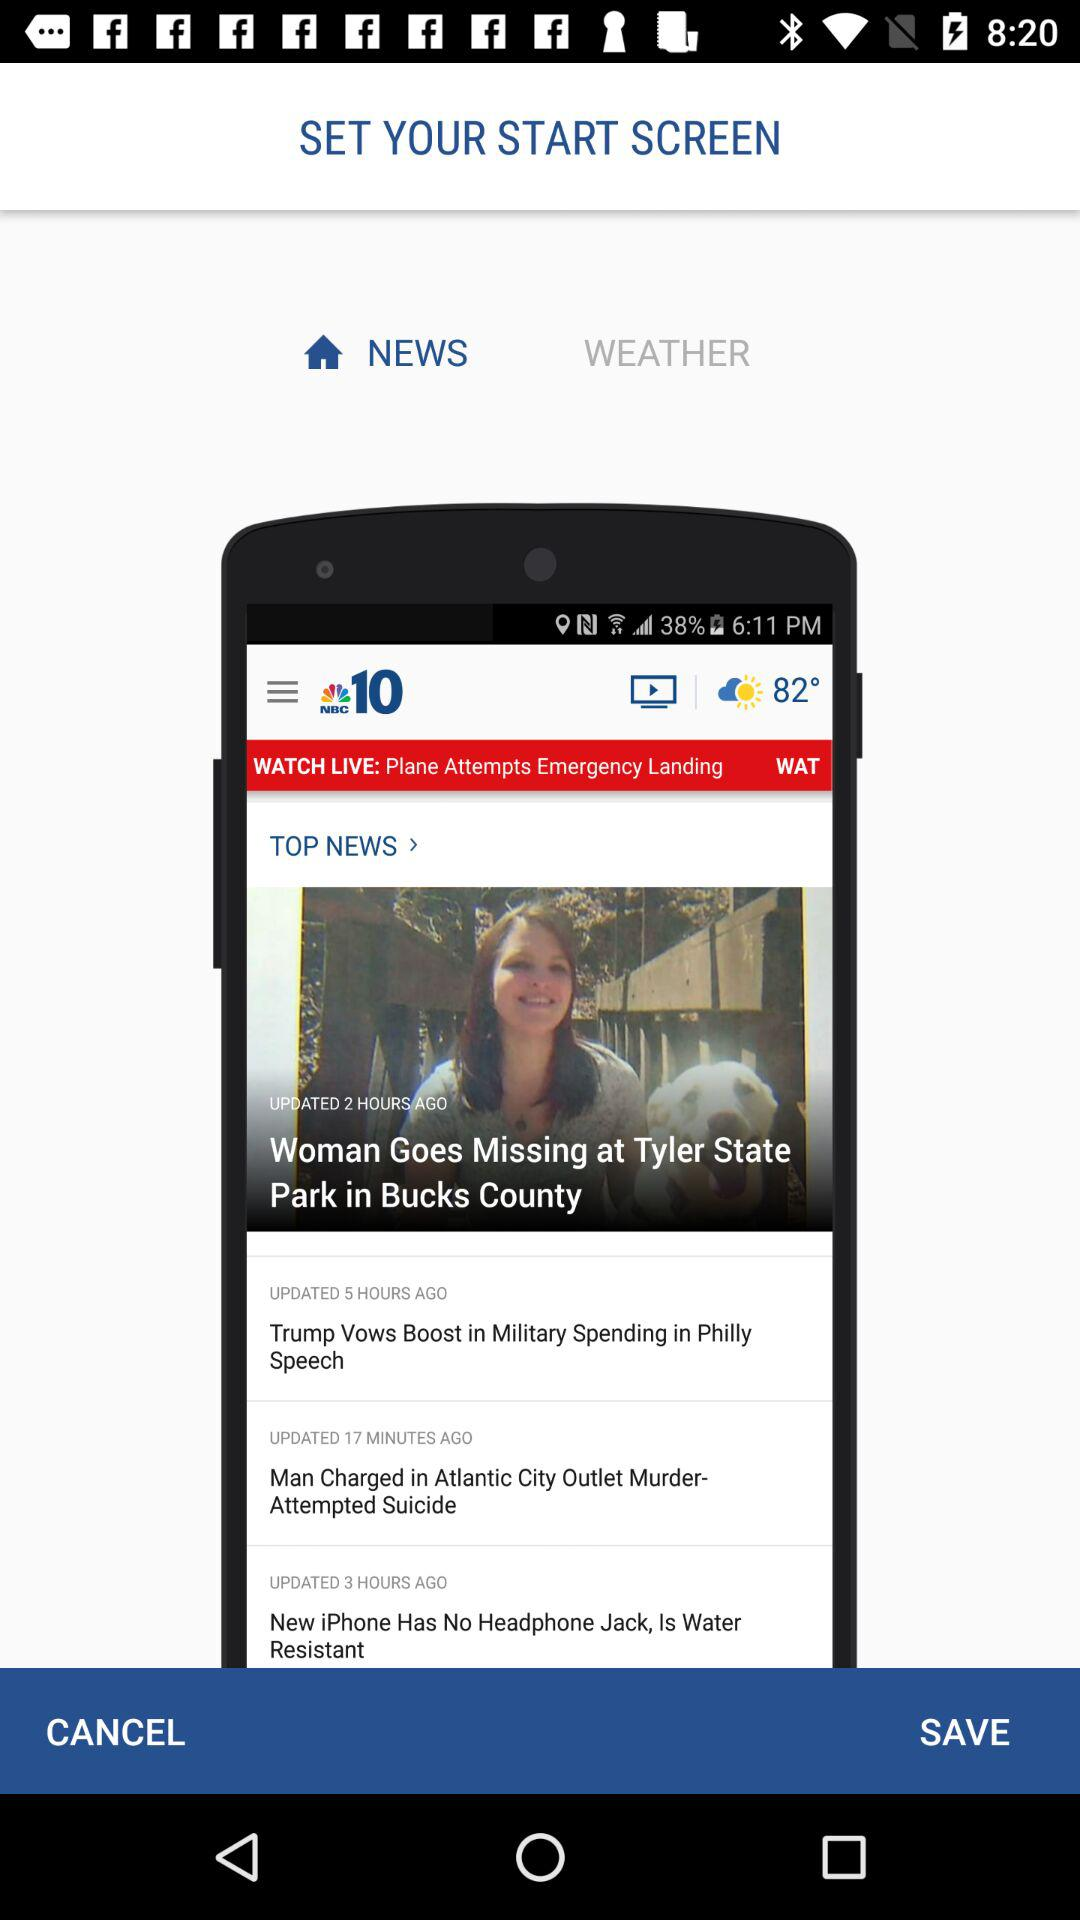When was the news "Woman Goes Missing at Tyler State Park in Bucks County" last updated? The news "Woman Goes Missing at Tyler State Park in Bucks County" was last updated 2 hours ago. 